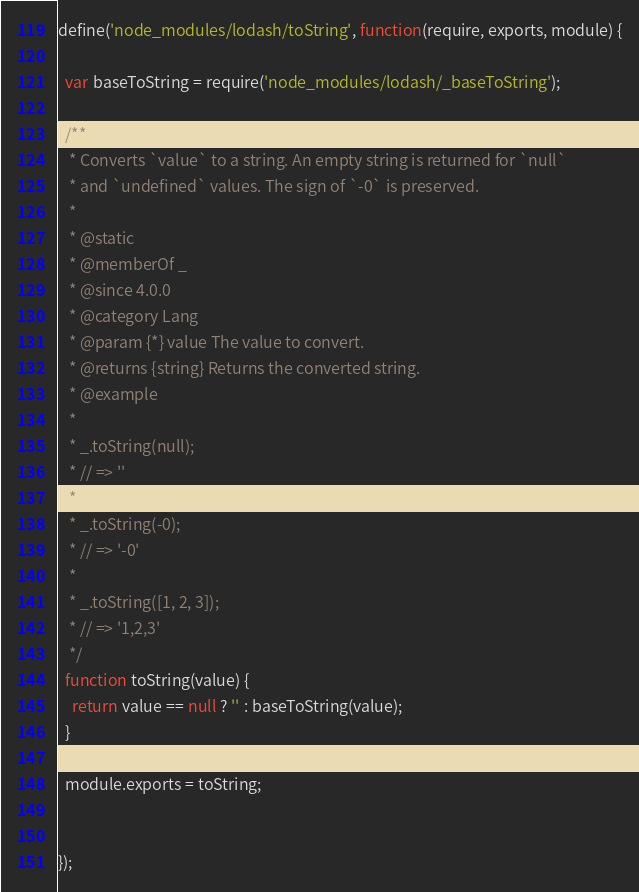Convert code to text. <code><loc_0><loc_0><loc_500><loc_500><_JavaScript_>define('node_modules/lodash/toString', function(require, exports, module) {

  var baseToString = require('node_modules/lodash/_baseToString');
  
  /**
   * Converts `value` to a string. An empty string is returned for `null`
   * and `undefined` values. The sign of `-0` is preserved.
   *
   * @static
   * @memberOf _
   * @since 4.0.0
   * @category Lang
   * @param {*} value The value to convert.
   * @returns {string} Returns the converted string.
   * @example
   *
   * _.toString(null);
   * // => ''
   *
   * _.toString(-0);
   * // => '-0'
   *
   * _.toString([1, 2, 3]);
   * // => '1,2,3'
   */
  function toString(value) {
    return value == null ? '' : baseToString(value);
  }
  
  module.exports = toString;
  

});
</code> 